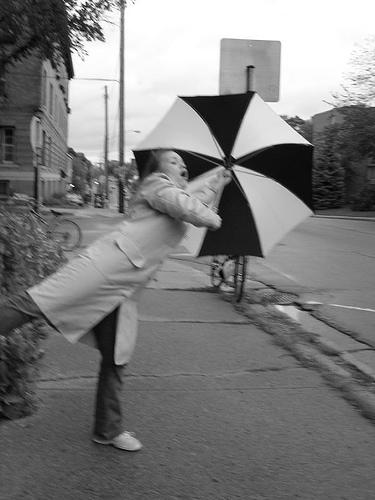If it isn't raining, why does the woman carry an umbrella?
Quick response, please. Sun. What foot is the person standing on?
Give a very brief answer. Left. What mode of transportation is shown?
Quick response, please. Bike. Is the umbrella keeping the boy dry?
Be succinct. No. Is it a windy day?
Concise answer only. Yes. How many umbrellas in the photo?
Short answer required. 1. Are the people under the umbrella carrying grocery bags?
Concise answer only. No. 